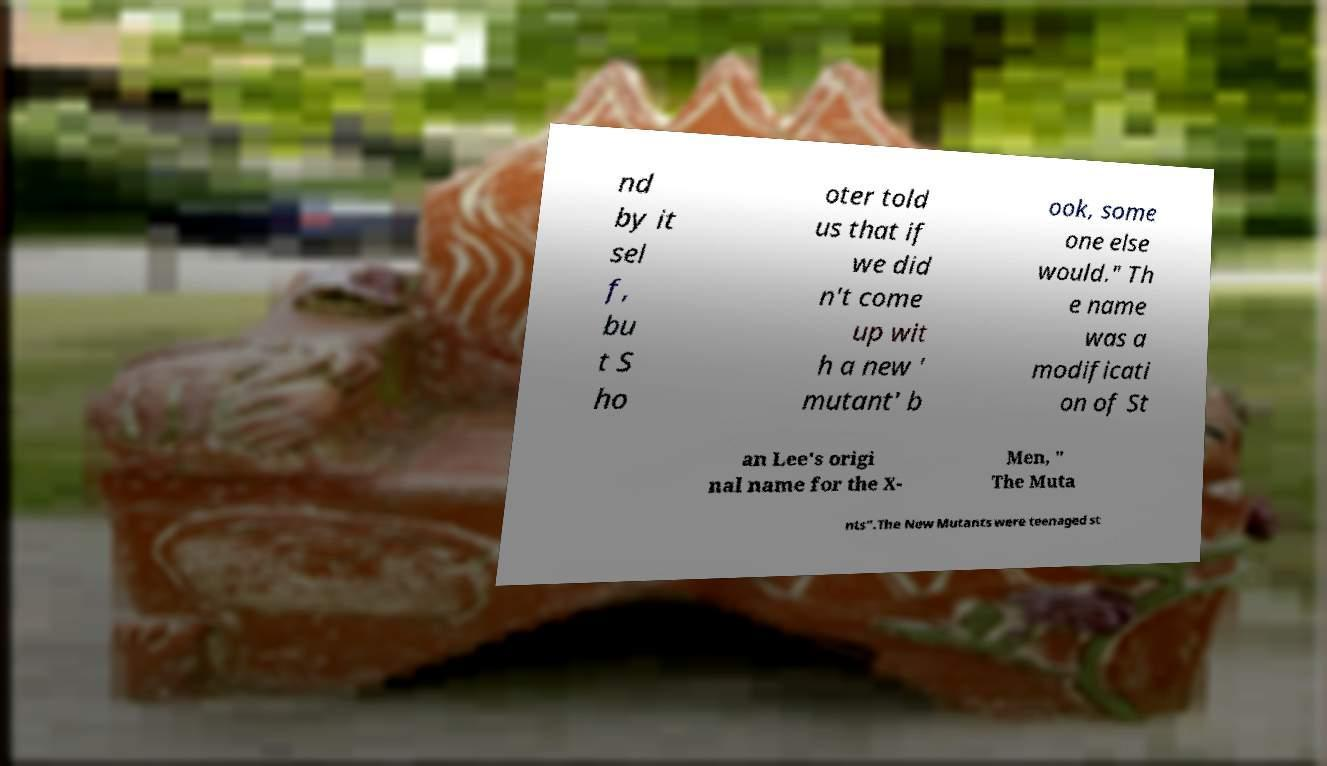What messages or text are displayed in this image? I need them in a readable, typed format. nd by it sel f, bu t S ho oter told us that if we did n't come up wit h a new ' mutant' b ook, some one else would." Th e name was a modificati on of St an Lee's origi nal name for the X- Men, " The Muta nts".The New Mutants were teenaged st 